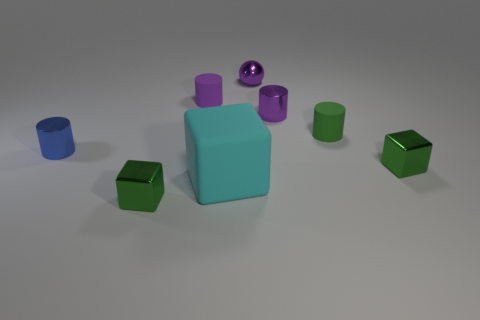Add 1 purple metal cylinders. How many objects exist? 9 Subtract all blocks. How many objects are left? 5 Add 6 purple rubber cylinders. How many purple rubber cylinders exist? 7 Subtract 0 gray cylinders. How many objects are left? 8 Subtract all tiny purple metallic balls. Subtract all tiny blue rubber objects. How many objects are left? 7 Add 2 purple matte objects. How many purple matte objects are left? 3 